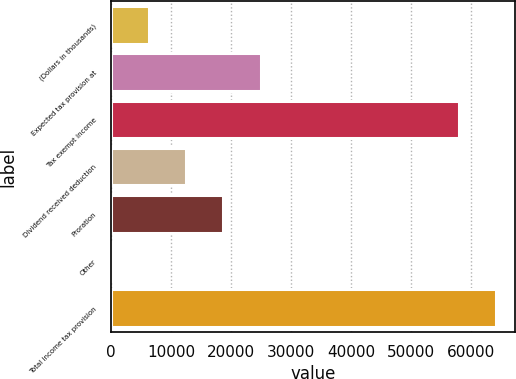Convert chart to OTSL. <chart><loc_0><loc_0><loc_500><loc_500><bar_chart><fcel>(Dollars in thousands)<fcel>Expected tax provision at<fcel>Tax exempt income<fcel>Dividend received deduction<fcel>Proration<fcel>Other<fcel>Total income tax provision<nl><fcel>6322.6<fcel>24966.4<fcel>57935<fcel>12537.2<fcel>18751.8<fcel>108<fcel>64149.6<nl></chart> 